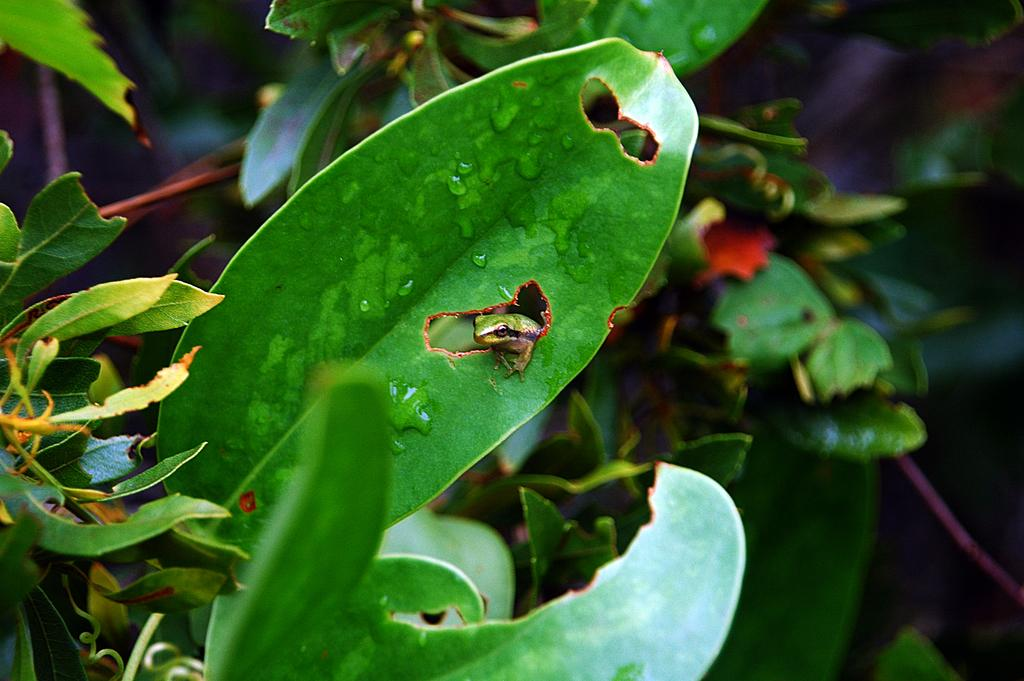What is the main subject in the center of the image? There is a leaf in the center of the image. What is on the leaf? There is a reptile on the leaf. What color is the reptile? The reptile is green in color. What can be seen in the background of the image? There are plants visible in the background of the image. What type of pot is being used for the feast in the image? There is no pot or feast present in the image; it features a leaf with a green reptile on it and plants in the background. 